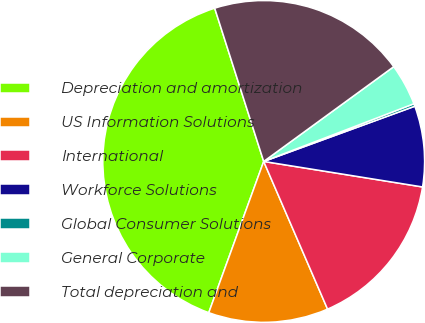Convert chart to OTSL. <chart><loc_0><loc_0><loc_500><loc_500><pie_chart><fcel>Depreciation and amortization<fcel>US Information Solutions<fcel>International<fcel>Workforce Solutions<fcel>Global Consumer Solutions<fcel>General Corporate<fcel>Total depreciation and<nl><fcel>39.53%<fcel>12.04%<fcel>15.97%<fcel>8.11%<fcel>0.26%<fcel>4.19%<fcel>19.9%<nl></chart> 